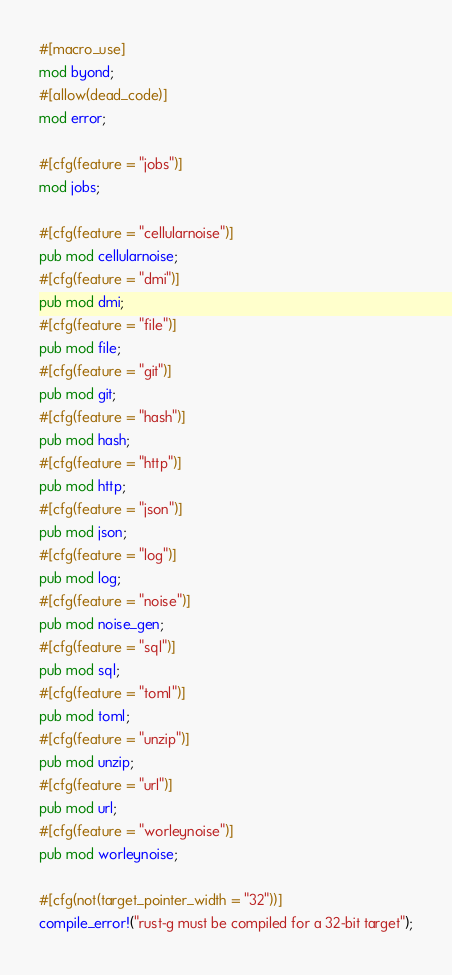Convert code to text. <code><loc_0><loc_0><loc_500><loc_500><_Rust_>#[macro_use]
mod byond;
#[allow(dead_code)]
mod error;

#[cfg(feature = "jobs")]
mod jobs;

#[cfg(feature = "cellularnoise")]
pub mod cellularnoise;
#[cfg(feature = "dmi")]
pub mod dmi;
#[cfg(feature = "file")]
pub mod file;
#[cfg(feature = "git")]
pub mod git;
#[cfg(feature = "hash")]
pub mod hash;
#[cfg(feature = "http")]
pub mod http;
#[cfg(feature = "json")]
pub mod json;
#[cfg(feature = "log")]
pub mod log;
#[cfg(feature = "noise")]
pub mod noise_gen;
#[cfg(feature = "sql")]
pub mod sql;
#[cfg(feature = "toml")]
pub mod toml;
#[cfg(feature = "unzip")]
pub mod unzip;
#[cfg(feature = "url")]
pub mod url;
#[cfg(feature = "worleynoise")]
pub mod worleynoise;

#[cfg(not(target_pointer_width = "32"))]
compile_error!("rust-g must be compiled for a 32-bit target");
</code> 